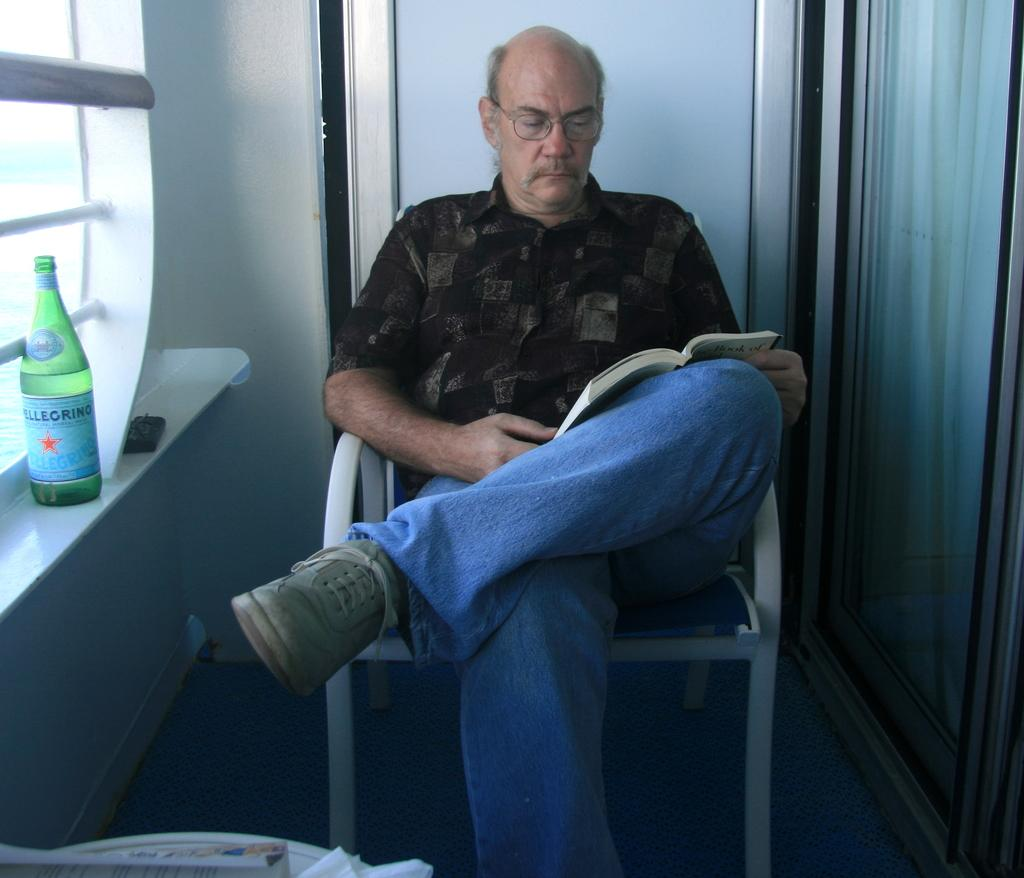Who is present in the image? There is a man in the image. What is the man doing in the image? The man is sitting on a chair in the image. What is the man holding in his hand? The man is holding a book in his hand. Can you describe any other objects in the image? There is a bottle on the wall in the image. What type of rhythm can be heard coming from the man's notebook in the image? There is no notebook present in the image, and therefore no rhythm can be heard. 